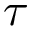Convert formula to latex. <formula><loc_0><loc_0><loc_500><loc_500>\tau</formula> 